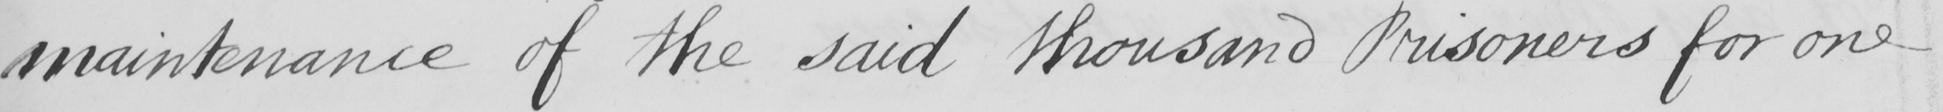What is written in this line of handwriting? maintenance of the said thousand Prisoners for one 